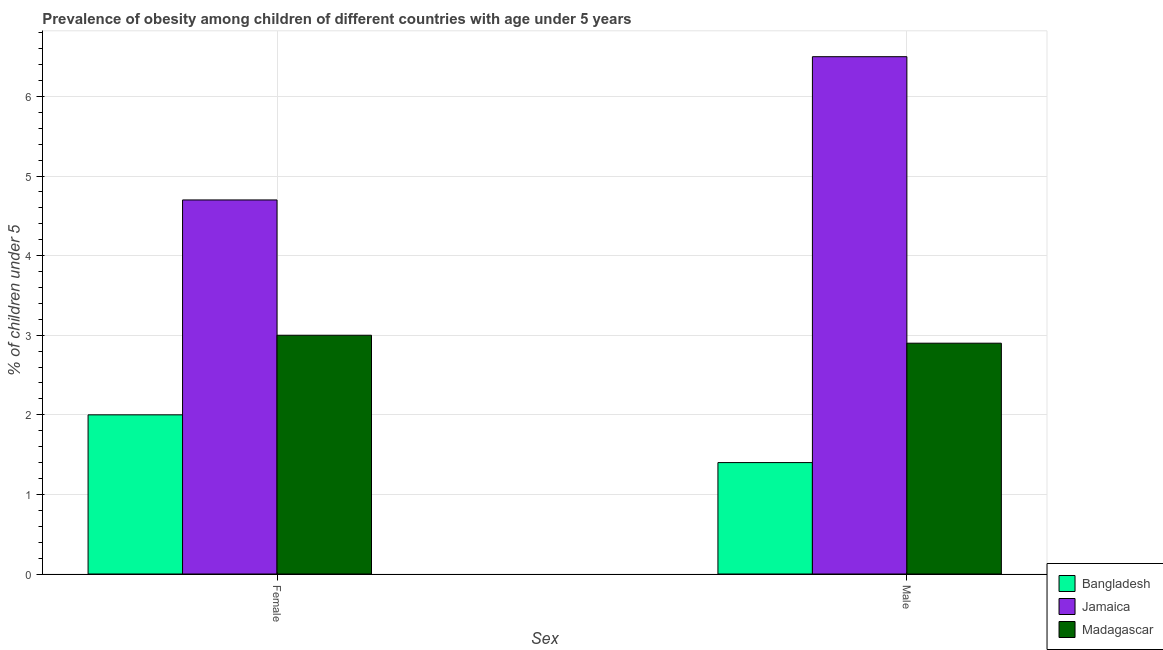How many different coloured bars are there?
Give a very brief answer. 3. Are the number of bars per tick equal to the number of legend labels?
Provide a short and direct response. Yes. Are the number of bars on each tick of the X-axis equal?
Your answer should be very brief. Yes. How many bars are there on the 2nd tick from the left?
Give a very brief answer. 3. How many bars are there on the 2nd tick from the right?
Your answer should be very brief. 3. What is the label of the 2nd group of bars from the left?
Give a very brief answer. Male. Across all countries, what is the maximum percentage of obese female children?
Offer a terse response. 4.7. Across all countries, what is the minimum percentage of obese female children?
Offer a very short reply. 2. In which country was the percentage of obese male children maximum?
Ensure brevity in your answer.  Jamaica. In which country was the percentage of obese female children minimum?
Your response must be concise. Bangladesh. What is the total percentage of obese male children in the graph?
Offer a terse response. 10.8. What is the difference between the percentage of obese male children in Madagascar and that in Bangladesh?
Keep it short and to the point. 1.5. What is the difference between the percentage of obese male children in Jamaica and the percentage of obese female children in Bangladesh?
Ensure brevity in your answer.  4.5. What is the average percentage of obese male children per country?
Give a very brief answer. 3.6. What is the difference between the percentage of obese male children and percentage of obese female children in Bangladesh?
Your answer should be compact. -0.6. What is the ratio of the percentage of obese female children in Madagascar to that in Jamaica?
Ensure brevity in your answer.  0.64. What does the 2nd bar from the left in Male represents?
Your answer should be very brief. Jamaica. What does the 2nd bar from the right in Male represents?
Provide a short and direct response. Jamaica. How many bars are there?
Your answer should be very brief. 6. How many countries are there in the graph?
Make the answer very short. 3. What is the difference between two consecutive major ticks on the Y-axis?
Offer a very short reply. 1. Are the values on the major ticks of Y-axis written in scientific E-notation?
Keep it short and to the point. No. How many legend labels are there?
Your answer should be compact. 3. What is the title of the graph?
Make the answer very short. Prevalence of obesity among children of different countries with age under 5 years. Does "Sub-Saharan Africa (developing only)" appear as one of the legend labels in the graph?
Provide a short and direct response. No. What is the label or title of the X-axis?
Your answer should be compact. Sex. What is the label or title of the Y-axis?
Give a very brief answer.  % of children under 5. What is the  % of children under 5 of Jamaica in Female?
Your answer should be very brief. 4.7. What is the  % of children under 5 of Madagascar in Female?
Make the answer very short. 3. What is the  % of children under 5 in Bangladesh in Male?
Provide a succinct answer. 1.4. What is the  % of children under 5 in Jamaica in Male?
Your answer should be very brief. 6.5. What is the  % of children under 5 in Madagascar in Male?
Keep it short and to the point. 2.9. Across all Sex, what is the maximum  % of children under 5 of Bangladesh?
Offer a very short reply. 2. Across all Sex, what is the maximum  % of children under 5 of Jamaica?
Offer a very short reply. 6.5. Across all Sex, what is the minimum  % of children under 5 in Bangladesh?
Your response must be concise. 1.4. Across all Sex, what is the minimum  % of children under 5 in Jamaica?
Ensure brevity in your answer.  4.7. Across all Sex, what is the minimum  % of children under 5 in Madagascar?
Your answer should be compact. 2.9. What is the total  % of children under 5 in Bangladesh in the graph?
Your answer should be very brief. 3.4. What is the difference between the  % of children under 5 of Bangladesh in Female and the  % of children under 5 of Madagascar in Male?
Keep it short and to the point. -0.9. What is the difference between the  % of children under 5 in Jamaica in Female and the  % of children under 5 in Madagascar in Male?
Your answer should be compact. 1.8. What is the average  % of children under 5 of Bangladesh per Sex?
Offer a terse response. 1.7. What is the average  % of children under 5 in Jamaica per Sex?
Offer a terse response. 5.6. What is the average  % of children under 5 of Madagascar per Sex?
Your answer should be compact. 2.95. What is the difference between the  % of children under 5 of Bangladesh and  % of children under 5 of Jamaica in Female?
Provide a succinct answer. -2.7. What is the difference between the  % of children under 5 in Bangladesh and  % of children under 5 in Madagascar in Female?
Make the answer very short. -1. What is the difference between the  % of children under 5 of Jamaica and  % of children under 5 of Madagascar in Female?
Provide a succinct answer. 1.7. What is the difference between the  % of children under 5 in Bangladesh and  % of children under 5 in Madagascar in Male?
Offer a terse response. -1.5. What is the difference between the  % of children under 5 of Jamaica and  % of children under 5 of Madagascar in Male?
Provide a succinct answer. 3.6. What is the ratio of the  % of children under 5 of Bangladesh in Female to that in Male?
Give a very brief answer. 1.43. What is the ratio of the  % of children under 5 in Jamaica in Female to that in Male?
Make the answer very short. 0.72. What is the ratio of the  % of children under 5 of Madagascar in Female to that in Male?
Provide a succinct answer. 1.03. What is the difference between the highest and the second highest  % of children under 5 of Madagascar?
Ensure brevity in your answer.  0.1. What is the difference between the highest and the lowest  % of children under 5 of Bangladesh?
Provide a short and direct response. 0.6. What is the difference between the highest and the lowest  % of children under 5 of Jamaica?
Offer a terse response. 1.8. What is the difference between the highest and the lowest  % of children under 5 in Madagascar?
Keep it short and to the point. 0.1. 